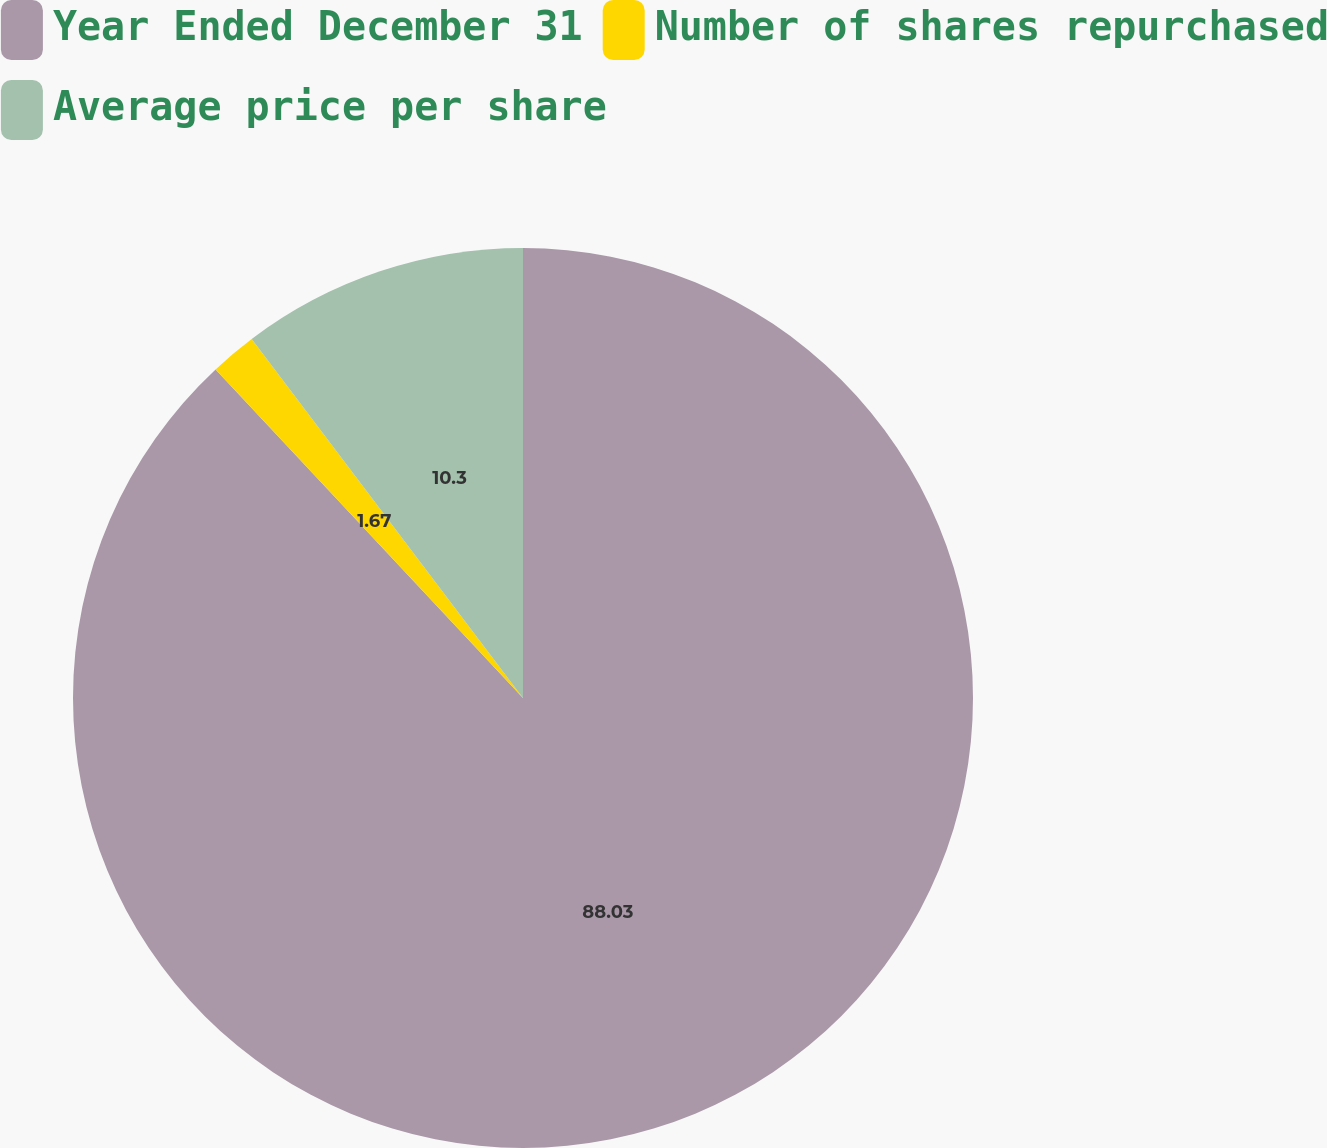Convert chart. <chart><loc_0><loc_0><loc_500><loc_500><pie_chart><fcel>Year Ended December 31<fcel>Number of shares repurchased<fcel>Average price per share<nl><fcel>88.03%<fcel>1.67%<fcel>10.3%<nl></chart> 